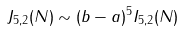<formula> <loc_0><loc_0><loc_500><loc_500>J _ { 5 , 2 } ( N ) \sim ( b - a ) ^ { 5 } I _ { 5 , 2 } ( N )</formula> 